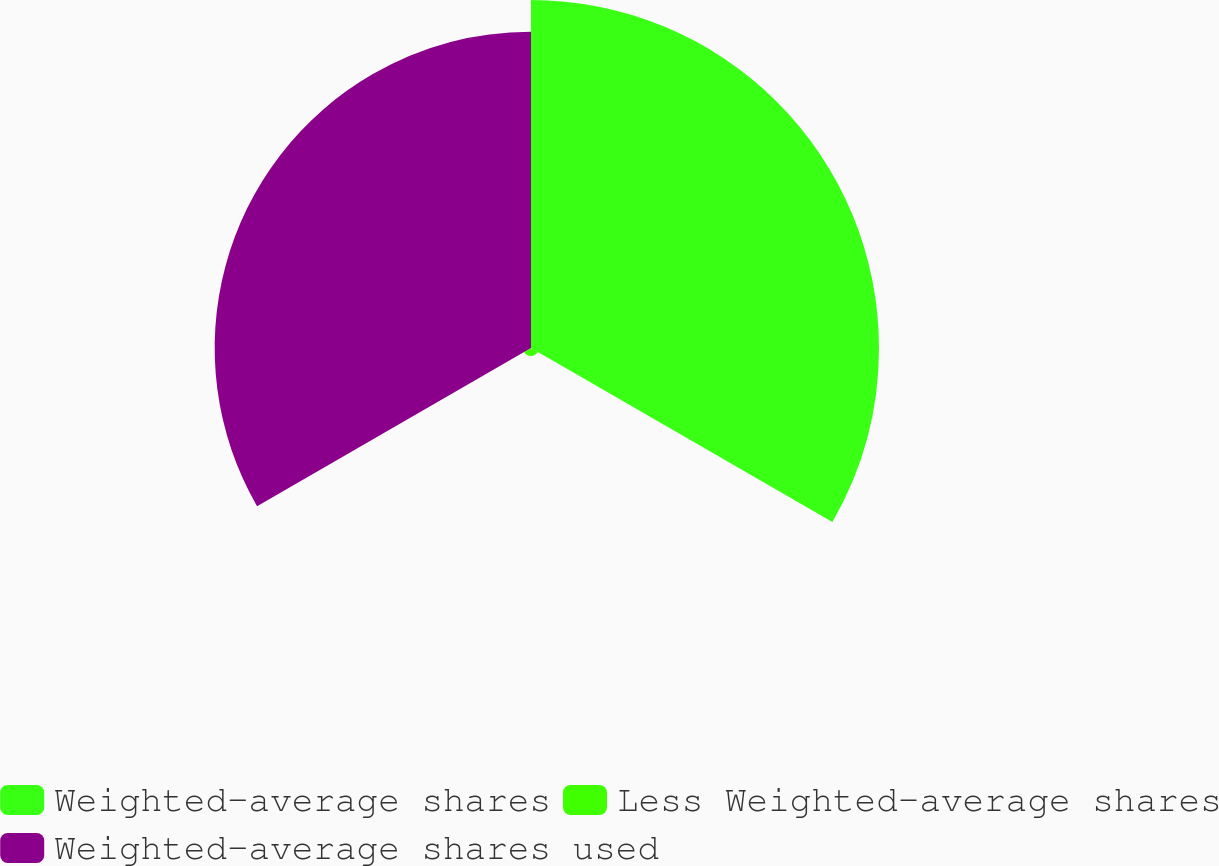Convert chart. <chart><loc_0><loc_0><loc_500><loc_500><pie_chart><fcel>Weighted-average shares<fcel>Less Weighted-average shares<fcel>Weighted-average shares used<nl><fcel>51.76%<fcel>1.19%<fcel>47.05%<nl></chart> 